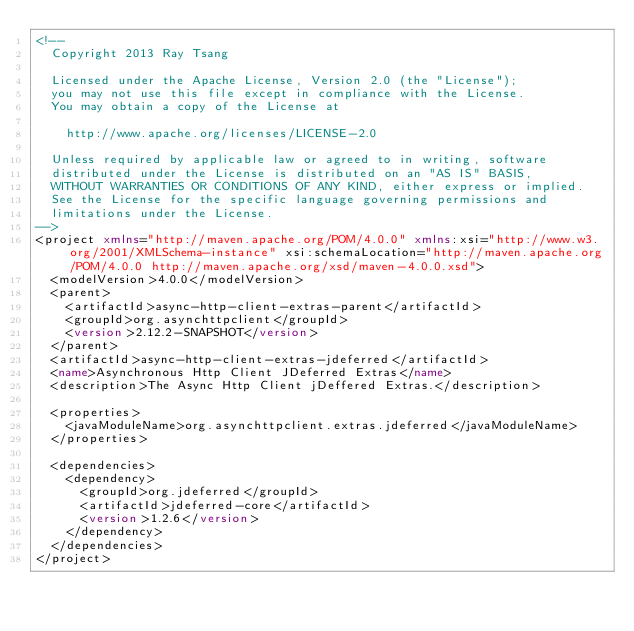<code> <loc_0><loc_0><loc_500><loc_500><_XML_><!--
  Copyright 2013 Ray Tsang
  
  Licensed under the Apache License, Version 2.0 (the "License");
  you may not use this file except in compliance with the License.
  You may obtain a copy of the License at
  
    http://www.apache.org/licenses/LICENSE-2.0
  
  Unless required by applicable law or agreed to in writing, software
  distributed under the License is distributed on an "AS IS" BASIS,
  WITHOUT WARRANTIES OR CONDITIONS OF ANY KIND, either express or implied.
  See the License for the specific language governing permissions and
  limitations under the License.
-->
<project xmlns="http://maven.apache.org/POM/4.0.0" xmlns:xsi="http://www.w3.org/2001/XMLSchema-instance" xsi:schemaLocation="http://maven.apache.org/POM/4.0.0 http://maven.apache.org/xsd/maven-4.0.0.xsd">
  <modelVersion>4.0.0</modelVersion>
  <parent>
    <artifactId>async-http-client-extras-parent</artifactId>
    <groupId>org.asynchttpclient</groupId>
    <version>2.12.2-SNAPSHOT</version>
  </parent>
  <artifactId>async-http-client-extras-jdeferred</artifactId>
  <name>Asynchronous Http Client JDeferred Extras</name>
  <description>The Async Http Client jDeffered Extras.</description>

  <properties>
    <javaModuleName>org.asynchttpclient.extras.jdeferred</javaModuleName>
  </properties>

  <dependencies>
    <dependency>
      <groupId>org.jdeferred</groupId>
      <artifactId>jdeferred-core</artifactId>
      <version>1.2.6</version>
    </dependency>
  </dependencies>
</project>
</code> 